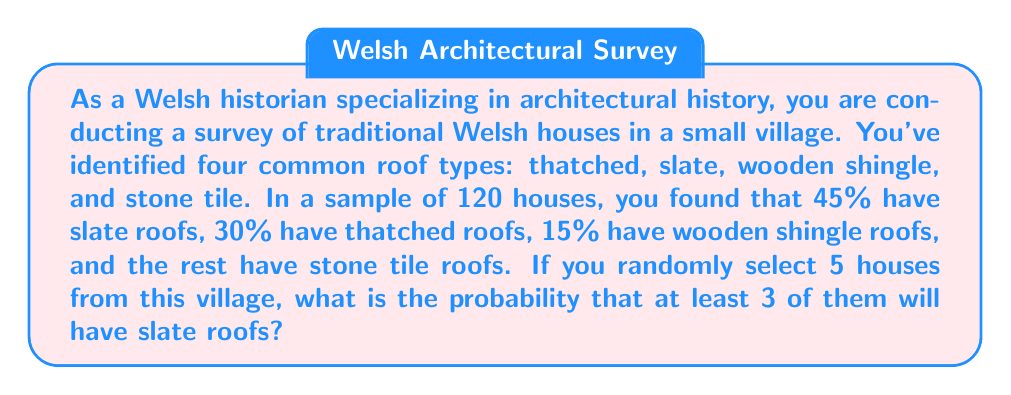Solve this math problem. To solve this problem, we'll use the binomial probability distribution. Let's break it down step-by-step:

1. First, let's identify the key information:
   - Total houses in the sample: 120
   - Probability of a slate roof: 45% = 0.45
   - We want at least 3 out of 5 houses to have slate roofs

2. We need to calculate the probability of exactly 3, 4, or 5 houses having slate roofs and sum these probabilities.

3. The binomial probability formula is:

   $$ P(X = k) = \binom{n}{k} p^k (1-p)^{n-k} $$

   Where:
   $n$ = number of trials (5 in this case)
   $k$ = number of successes
   $p$ = probability of success on each trial (0.45)

4. Let's calculate each probability:

   For 3 slate roofs:
   $$ P(X = 3) = \binom{5}{3} (0.45)^3 (0.55)^2 = 10 \times 0.091125 \times 0.3025 = 0.2755 $$

   For 4 slate roofs:
   $$ P(X = 4) = \binom{5}{4} (0.45)^4 (0.55)^1 = 5 \times 0.041006 \times 0.55 = 0.1128 $$

   For 5 slate roofs:
   $$ P(X = 5) = \binom{5}{5} (0.45)^5 (0.55)^0 = 1 \times 0.018453 \times 1 = 0.0185 $$

5. Now, we sum these probabilities:

   $$ P(X \geq 3) = P(X = 3) + P(X = 4) + P(X = 5) = 0.2755 + 0.1128 + 0.0185 = 0.4068 $$

Therefore, the probability of at least 3 out of 5 randomly selected houses having slate roofs is approximately 0.4068 or 40.68%.
Answer: 0.4068 or 40.68% 